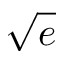Convert formula to latex. <formula><loc_0><loc_0><loc_500><loc_500>\sqrt { e }</formula> 